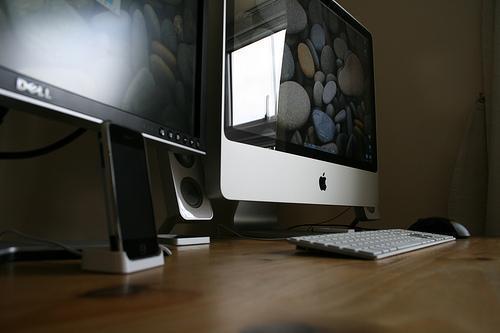How many white computers are there?
Give a very brief answer. 1. 